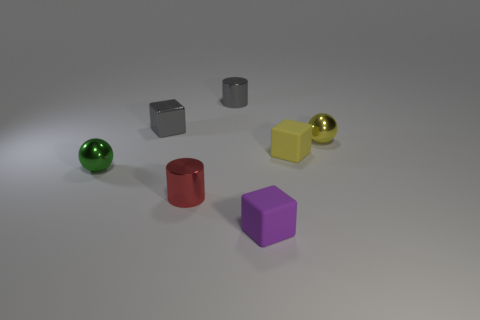Subtract 1 cubes. How many cubes are left? 2 Add 3 tiny green metal balls. How many objects exist? 10 Subtract all balls. How many objects are left? 5 Add 3 small green balls. How many small green balls are left? 4 Add 5 tiny blue balls. How many tiny blue balls exist? 5 Subtract 0 yellow cylinders. How many objects are left? 7 Subtract all small red objects. Subtract all gray things. How many objects are left? 4 